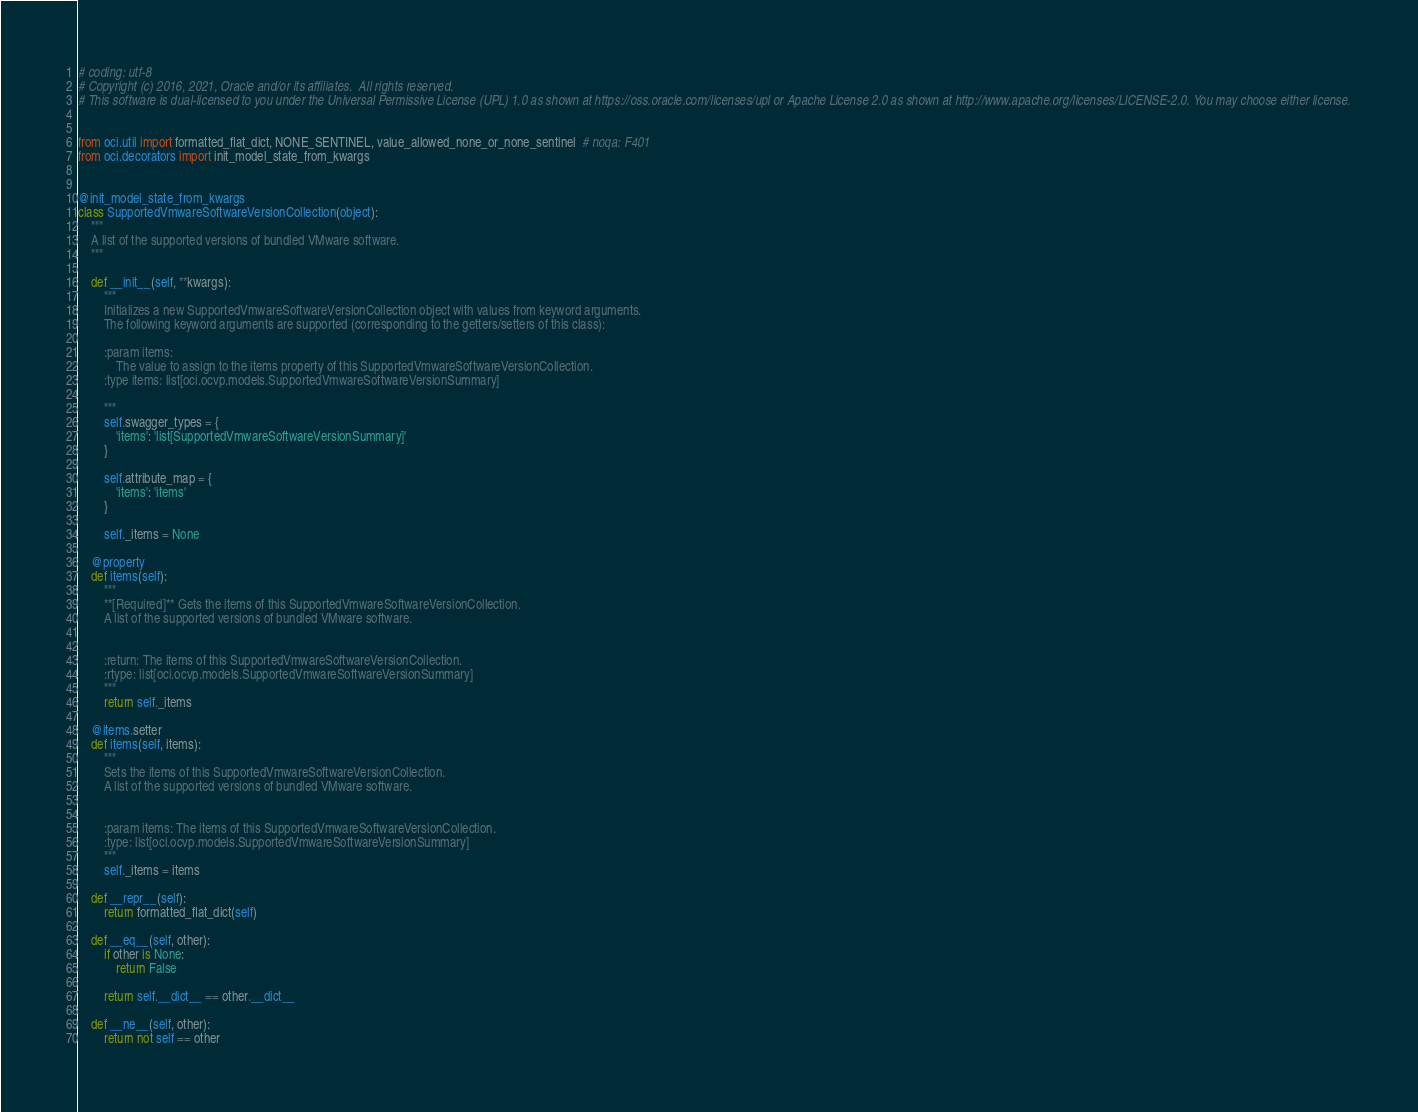Convert code to text. <code><loc_0><loc_0><loc_500><loc_500><_Python_># coding: utf-8
# Copyright (c) 2016, 2021, Oracle and/or its affiliates.  All rights reserved.
# This software is dual-licensed to you under the Universal Permissive License (UPL) 1.0 as shown at https://oss.oracle.com/licenses/upl or Apache License 2.0 as shown at http://www.apache.org/licenses/LICENSE-2.0. You may choose either license.


from oci.util import formatted_flat_dict, NONE_SENTINEL, value_allowed_none_or_none_sentinel  # noqa: F401
from oci.decorators import init_model_state_from_kwargs


@init_model_state_from_kwargs
class SupportedVmwareSoftwareVersionCollection(object):
    """
    A list of the supported versions of bundled VMware software.
    """

    def __init__(self, **kwargs):
        """
        Initializes a new SupportedVmwareSoftwareVersionCollection object with values from keyword arguments.
        The following keyword arguments are supported (corresponding to the getters/setters of this class):

        :param items:
            The value to assign to the items property of this SupportedVmwareSoftwareVersionCollection.
        :type items: list[oci.ocvp.models.SupportedVmwareSoftwareVersionSummary]

        """
        self.swagger_types = {
            'items': 'list[SupportedVmwareSoftwareVersionSummary]'
        }

        self.attribute_map = {
            'items': 'items'
        }

        self._items = None

    @property
    def items(self):
        """
        **[Required]** Gets the items of this SupportedVmwareSoftwareVersionCollection.
        A list of the supported versions of bundled VMware software.


        :return: The items of this SupportedVmwareSoftwareVersionCollection.
        :rtype: list[oci.ocvp.models.SupportedVmwareSoftwareVersionSummary]
        """
        return self._items

    @items.setter
    def items(self, items):
        """
        Sets the items of this SupportedVmwareSoftwareVersionCollection.
        A list of the supported versions of bundled VMware software.


        :param items: The items of this SupportedVmwareSoftwareVersionCollection.
        :type: list[oci.ocvp.models.SupportedVmwareSoftwareVersionSummary]
        """
        self._items = items

    def __repr__(self):
        return formatted_flat_dict(self)

    def __eq__(self, other):
        if other is None:
            return False

        return self.__dict__ == other.__dict__

    def __ne__(self, other):
        return not self == other
</code> 